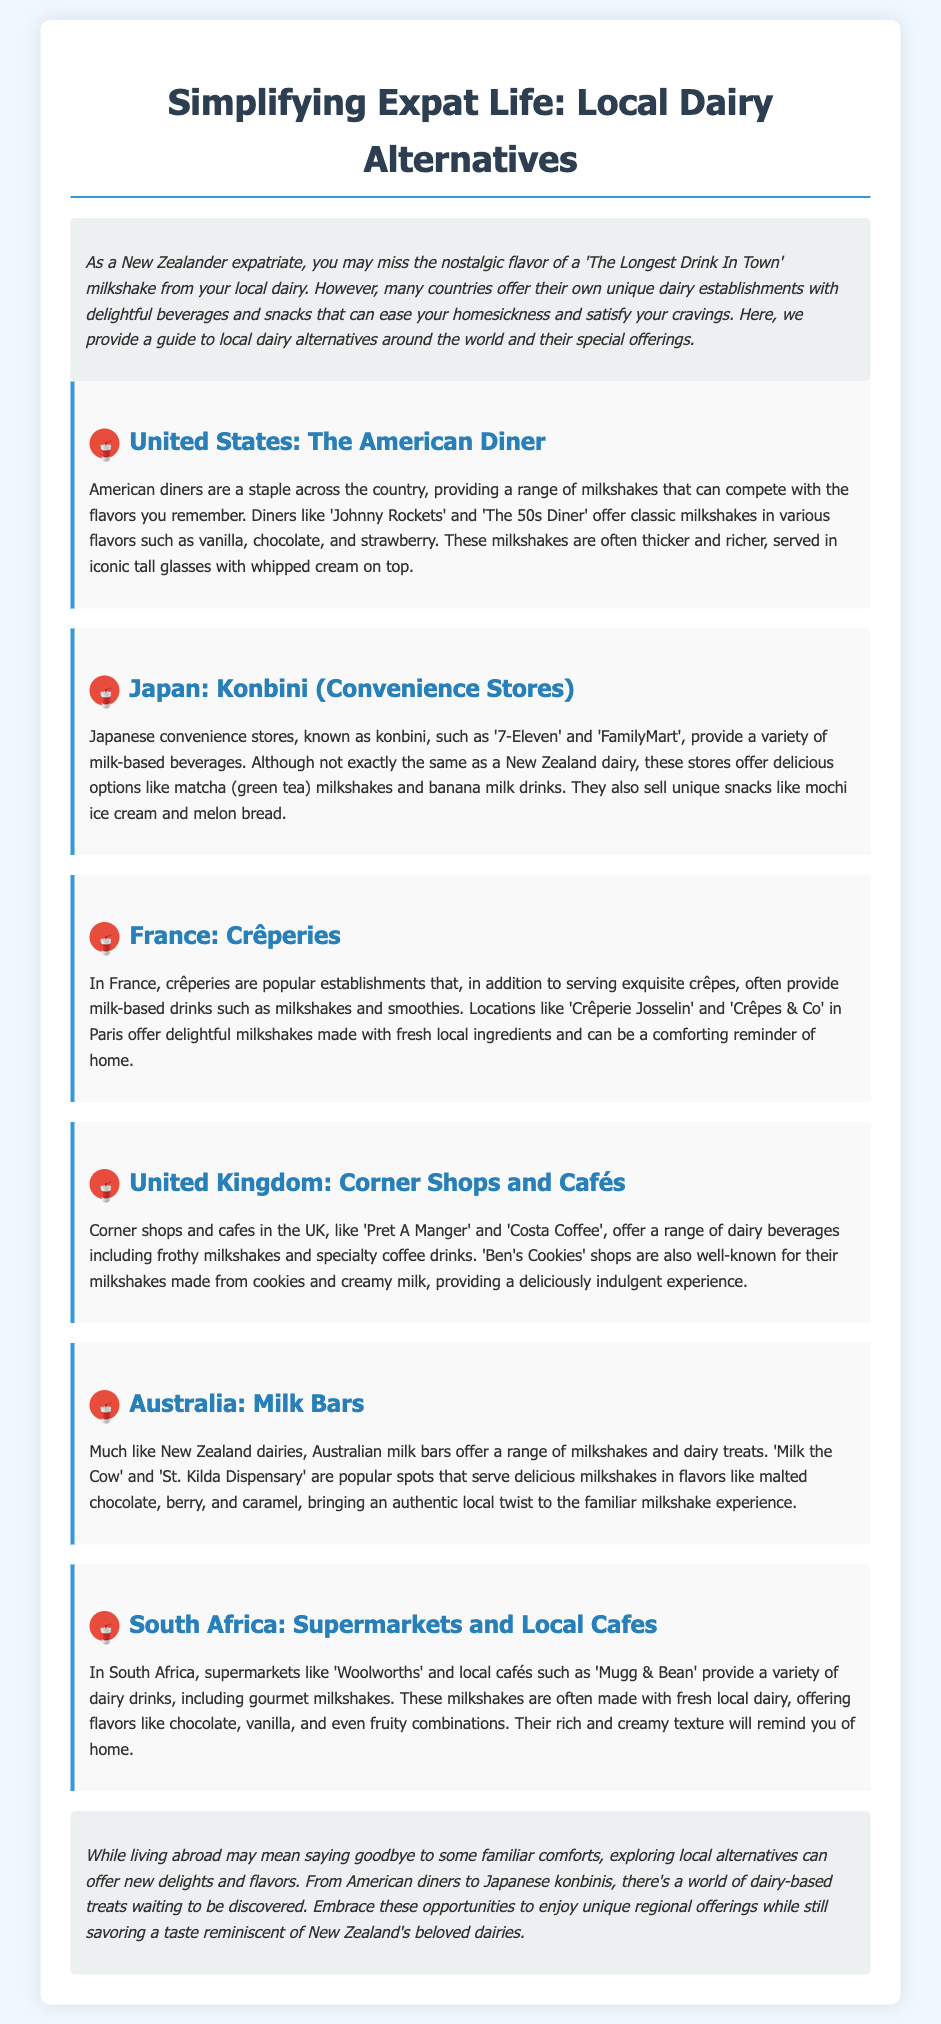what is the title of the document? The title is centrally located at the top of the document, indicating the theme of simplifying expat life.
Answer: Simplifying Expat Life: Local Dairy Alternatives what type of establishments are featured in the United States section? The section discusses diners, which are popular establishments known for their food and beverage offerings.
Answer: Diners which Japanese convenience store is mentioned in the document? The document specifies certain convenience stores that are well-known in Japan for their milk-based drinks.
Answer: 7-Eleven how many countries are highlighted in this document? The document details dairy alternatives from several countries, which can be counted from the sections provided.
Answer: Six what unique beverage offering is mentioned from Japanese konbini? The text describes a specific flavor of milk drink available in Japanese convenience stores.
Answer: Matcha milkshake which country’s dairy alternatives are compared to New Zealand's dairies? The document makes a direct comparison through the description of beverages and treats available in certain establishments.
Answer: Australia what is the overall theme of the conclusion? The conclusion reflects on the experience of finding local alternatives while living abroad, emphasizing comfort in exploration.
Answer: Exploring local alternatives name one unique snack available at Japanese konbini. The document mentions a variety of snacks available in Japanese convenience stores along with their drinks.
Answer: Mochi ice cream 